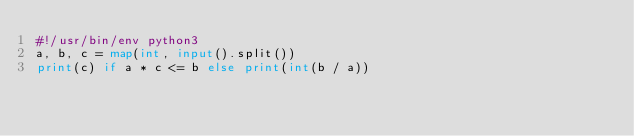Convert code to text. <code><loc_0><loc_0><loc_500><loc_500><_Python_>#!/usr/bin/env python3
a, b, c = map(int, input().split())
print(c) if a * c <= b else print(int(b / a))
    
</code> 